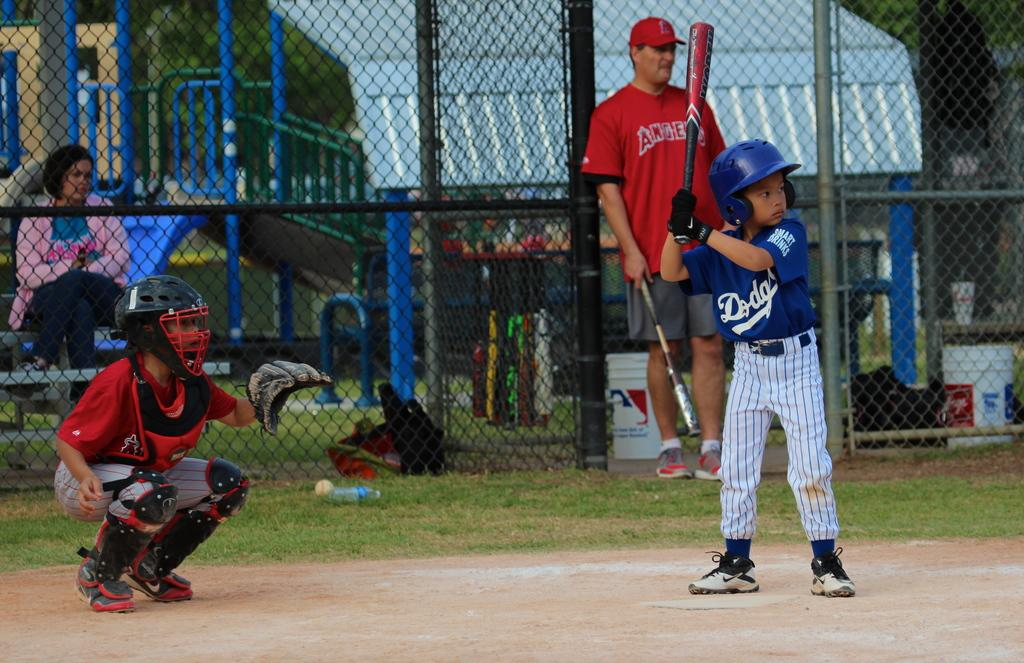<image>
Create a compact narrative representing the image presented. A boy in a Dodgers baseball uniform gets ready to bat. 